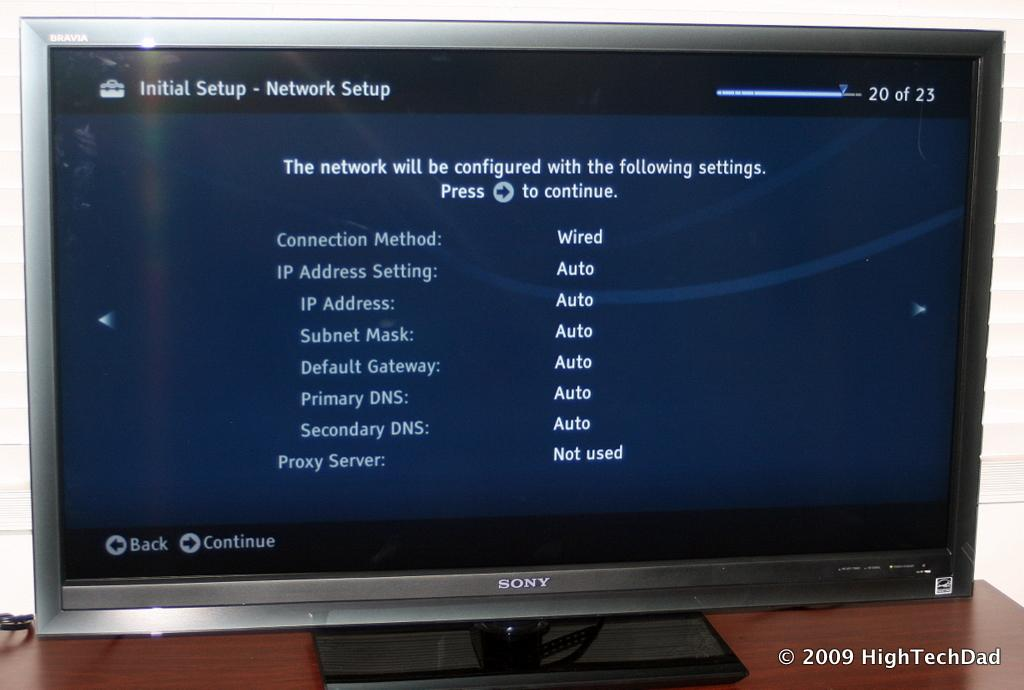Provide a one-sentence caption for the provided image. The television is connected by wire and is not using a Proxy Server. 